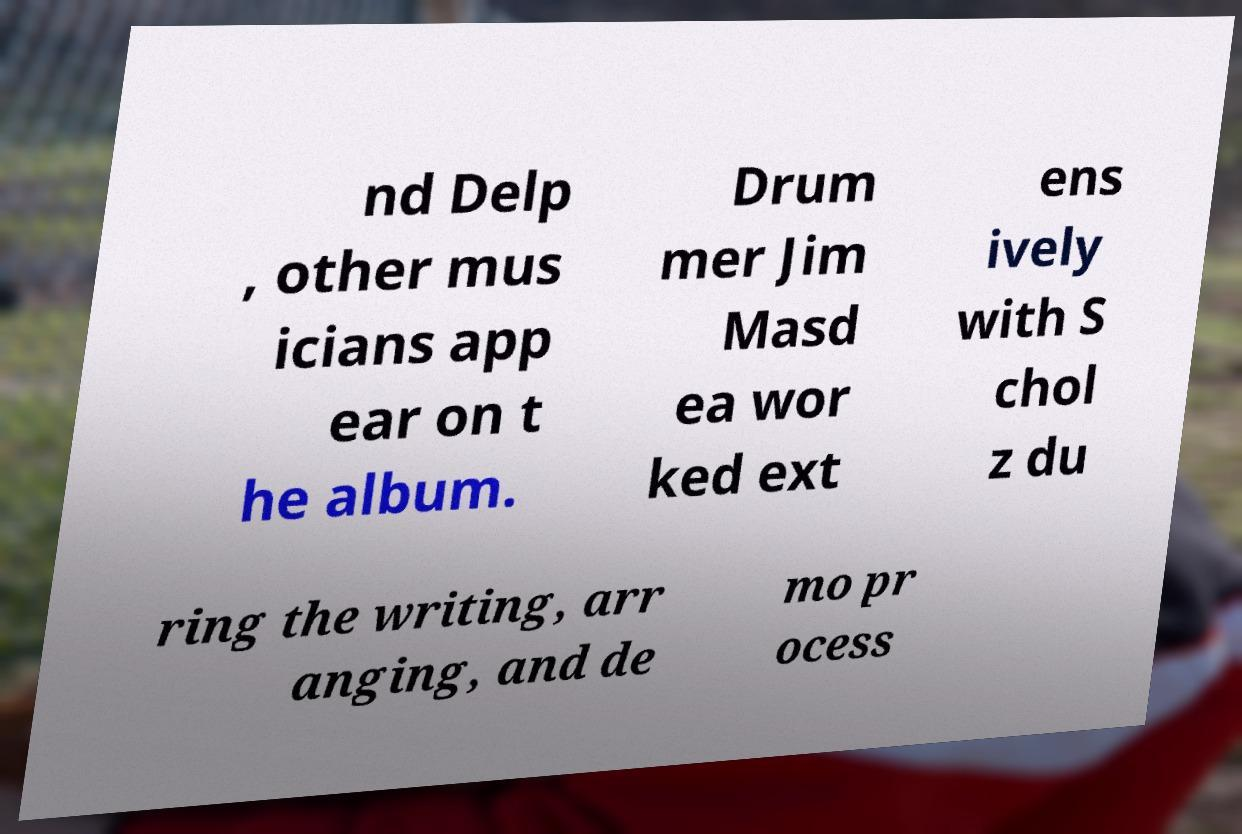Could you extract and type out the text from this image? nd Delp , other mus icians app ear on t he album. Drum mer Jim Masd ea wor ked ext ens ively with S chol z du ring the writing, arr anging, and de mo pr ocess 